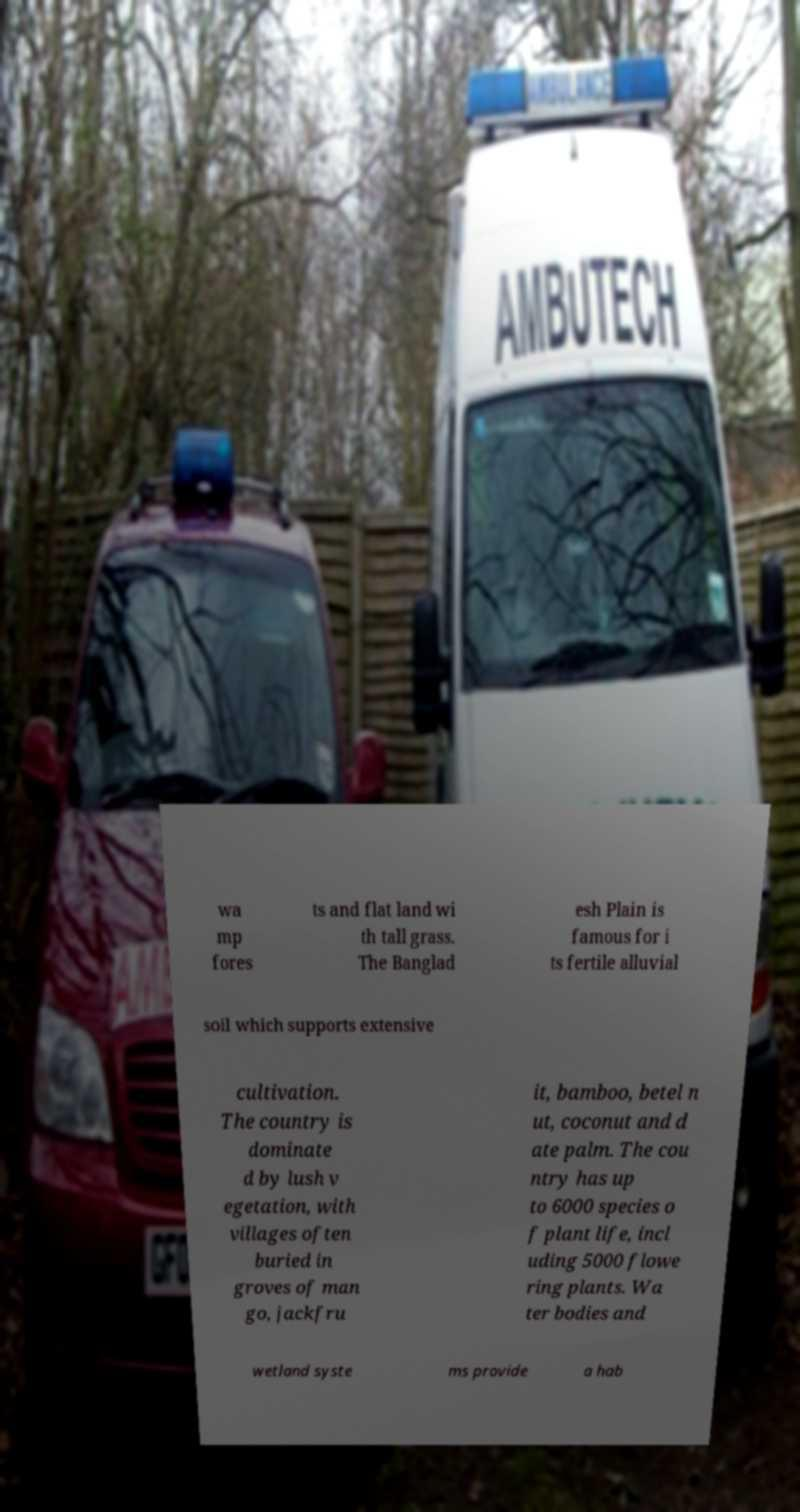What messages or text are displayed in this image? I need them in a readable, typed format. wa mp fores ts and flat land wi th tall grass. The Banglad esh Plain is famous for i ts fertile alluvial soil which supports extensive cultivation. The country is dominate d by lush v egetation, with villages often buried in groves of man go, jackfru it, bamboo, betel n ut, coconut and d ate palm. The cou ntry has up to 6000 species o f plant life, incl uding 5000 flowe ring plants. Wa ter bodies and wetland syste ms provide a hab 